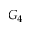<formula> <loc_0><loc_0><loc_500><loc_500>G _ { 4 }</formula> 